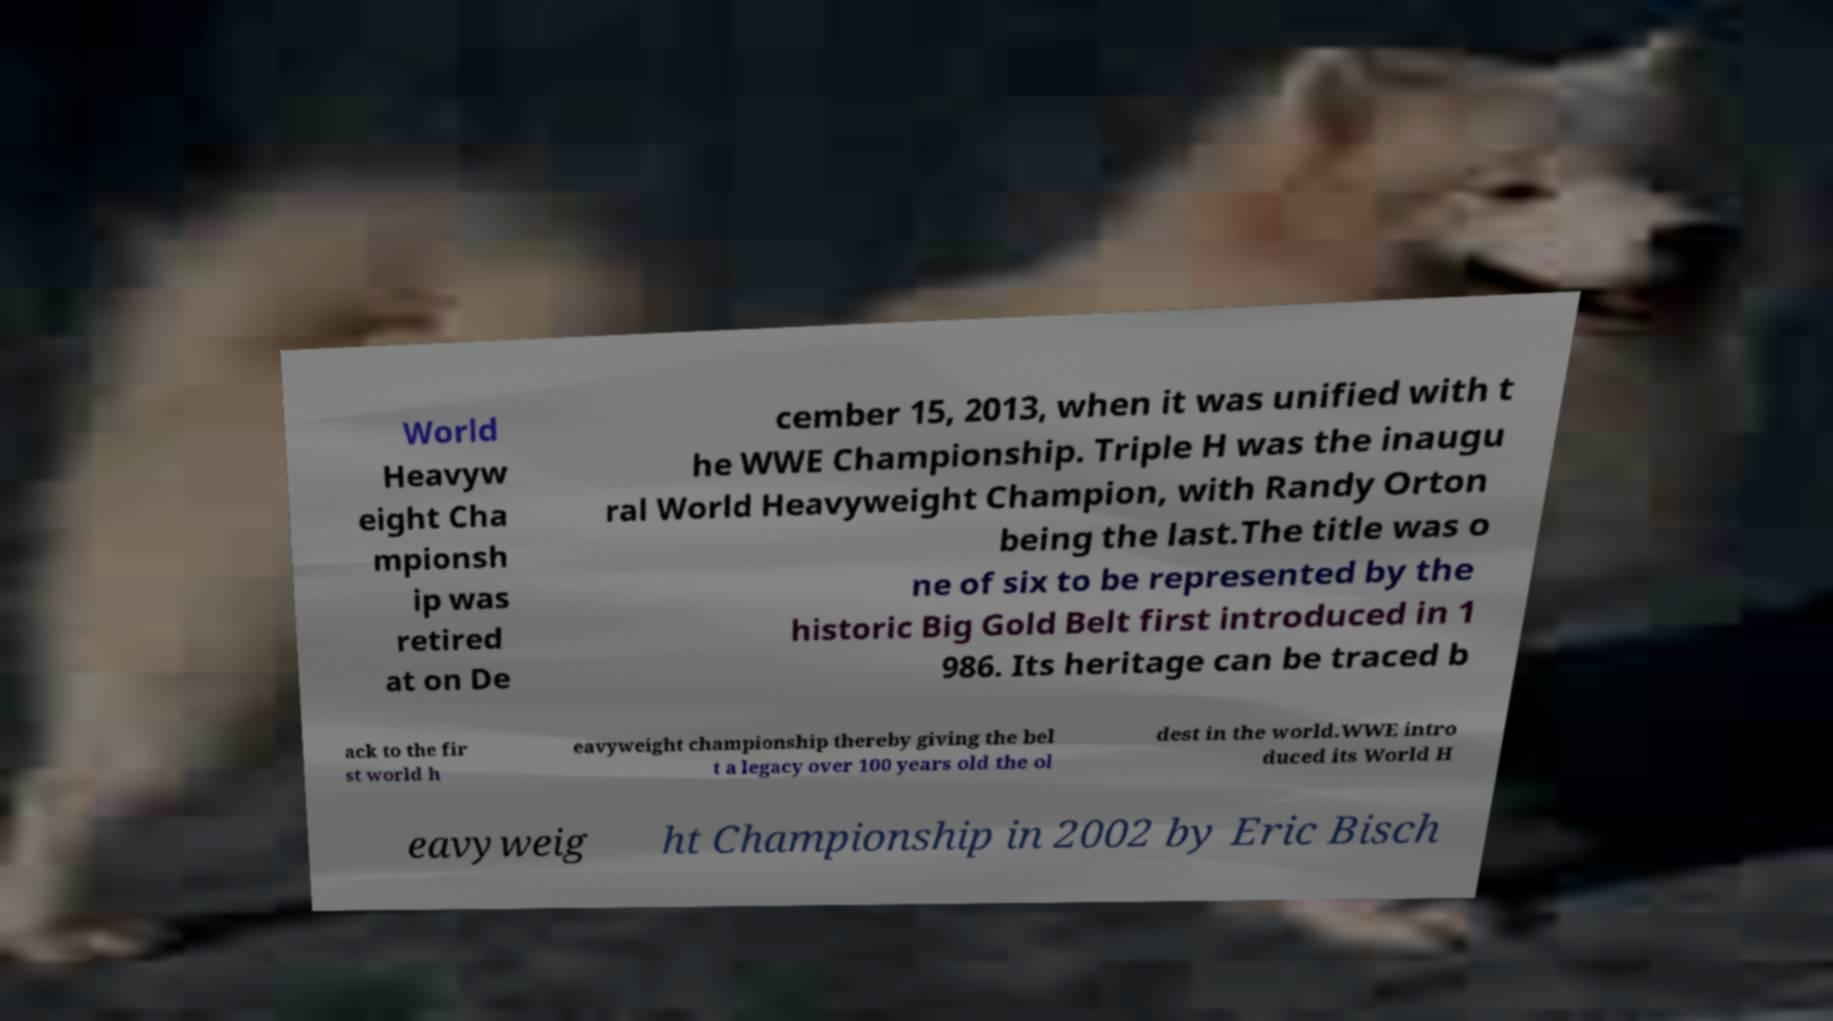Can you read and provide the text displayed in the image?This photo seems to have some interesting text. Can you extract and type it out for me? World Heavyw eight Cha mpionsh ip was retired at on De cember 15, 2013, when it was unified with t he WWE Championship. Triple H was the inaugu ral World Heavyweight Champion, with Randy Orton being the last.The title was o ne of six to be represented by the historic Big Gold Belt first introduced in 1 986. Its heritage can be traced b ack to the fir st world h eavyweight championship thereby giving the bel t a legacy over 100 years old the ol dest in the world.WWE intro duced its World H eavyweig ht Championship in 2002 by Eric Bisch 